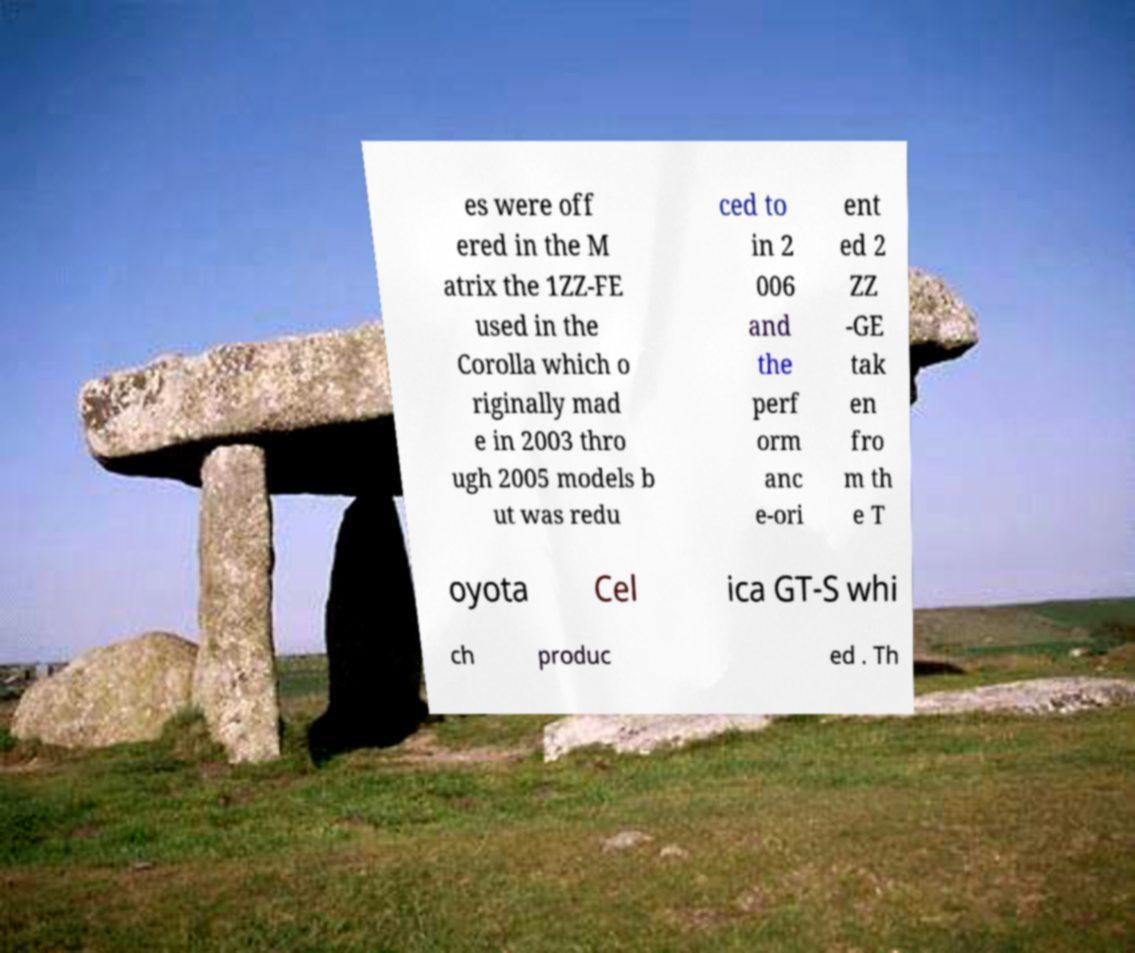Could you extract and type out the text from this image? es were off ered in the M atrix the 1ZZ-FE used in the Corolla which o riginally mad e in 2003 thro ugh 2005 models b ut was redu ced to in 2 006 and the perf orm anc e-ori ent ed 2 ZZ -GE tak en fro m th e T oyota Cel ica GT-S whi ch produc ed . Th 